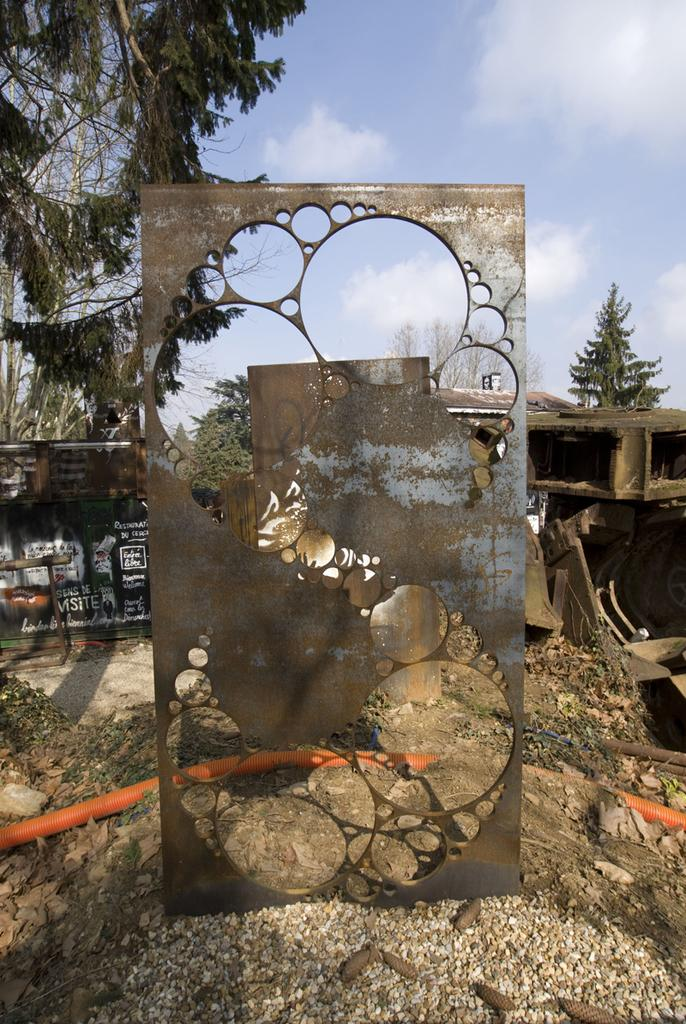What type of structure is visible in the image? There is a steel frame in the image. What can be seen behind the steel frame? There are objects behind the steel frame. Is there any text present in the image? Yes, there is a frame with text in the image. What type of natural environment is visible in the image? There are trees and grass in the image. What is visible in the sky in the image? There are clouds in the sky in the image. What type of loaf is being used to create the steel frame in the image? There is no loaf present in the image; the frame is made of steel. What type of skin can be seen on the trees in the image? The trees in the image do not have skin; they have bark. 